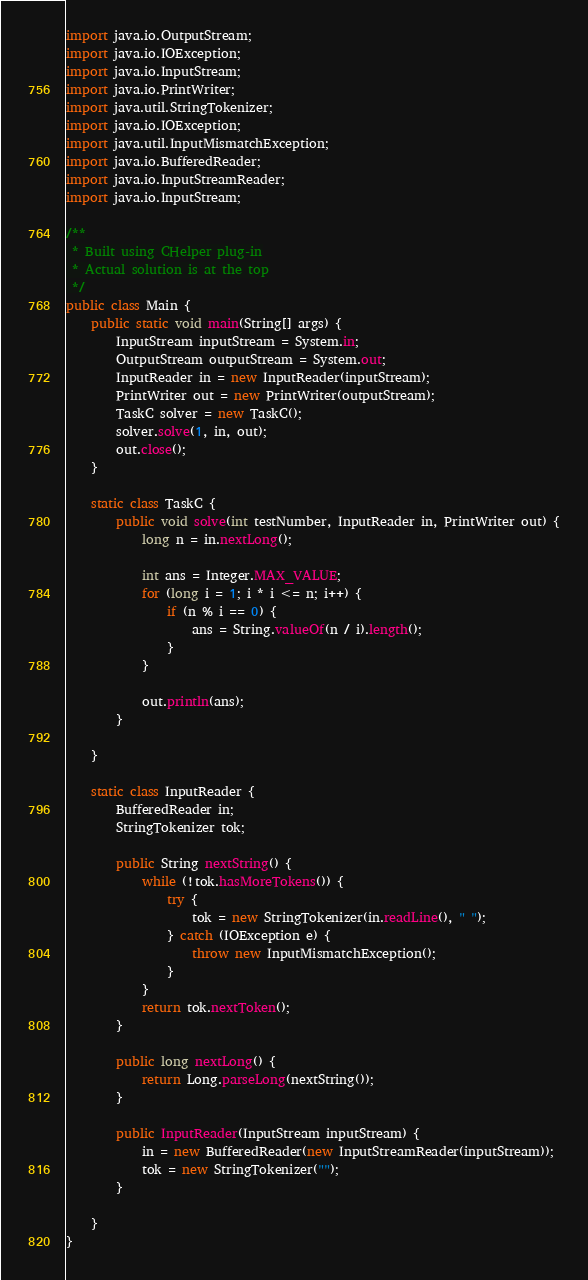Convert code to text. <code><loc_0><loc_0><loc_500><loc_500><_Java_>import java.io.OutputStream;
import java.io.IOException;
import java.io.InputStream;
import java.io.PrintWriter;
import java.util.StringTokenizer;
import java.io.IOException;
import java.util.InputMismatchException;
import java.io.BufferedReader;
import java.io.InputStreamReader;
import java.io.InputStream;

/**
 * Built using CHelper plug-in
 * Actual solution is at the top
 */
public class Main {
    public static void main(String[] args) {
        InputStream inputStream = System.in;
        OutputStream outputStream = System.out;
        InputReader in = new InputReader(inputStream);
        PrintWriter out = new PrintWriter(outputStream);
        TaskC solver = new TaskC();
        solver.solve(1, in, out);
        out.close();
    }

    static class TaskC {
        public void solve(int testNumber, InputReader in, PrintWriter out) {
            long n = in.nextLong();

            int ans = Integer.MAX_VALUE;
            for (long i = 1; i * i <= n; i++) {
                if (n % i == 0) {
                    ans = String.valueOf(n / i).length();
                }
            }

            out.println(ans);
        }

    }

    static class InputReader {
        BufferedReader in;
        StringTokenizer tok;

        public String nextString() {
            while (!tok.hasMoreTokens()) {
                try {
                    tok = new StringTokenizer(in.readLine(), " ");
                } catch (IOException e) {
                    throw new InputMismatchException();
                }
            }
            return tok.nextToken();
        }

        public long nextLong() {
            return Long.parseLong(nextString());
        }

        public InputReader(InputStream inputStream) {
            in = new BufferedReader(new InputStreamReader(inputStream));
            tok = new StringTokenizer("");
        }

    }
}

</code> 